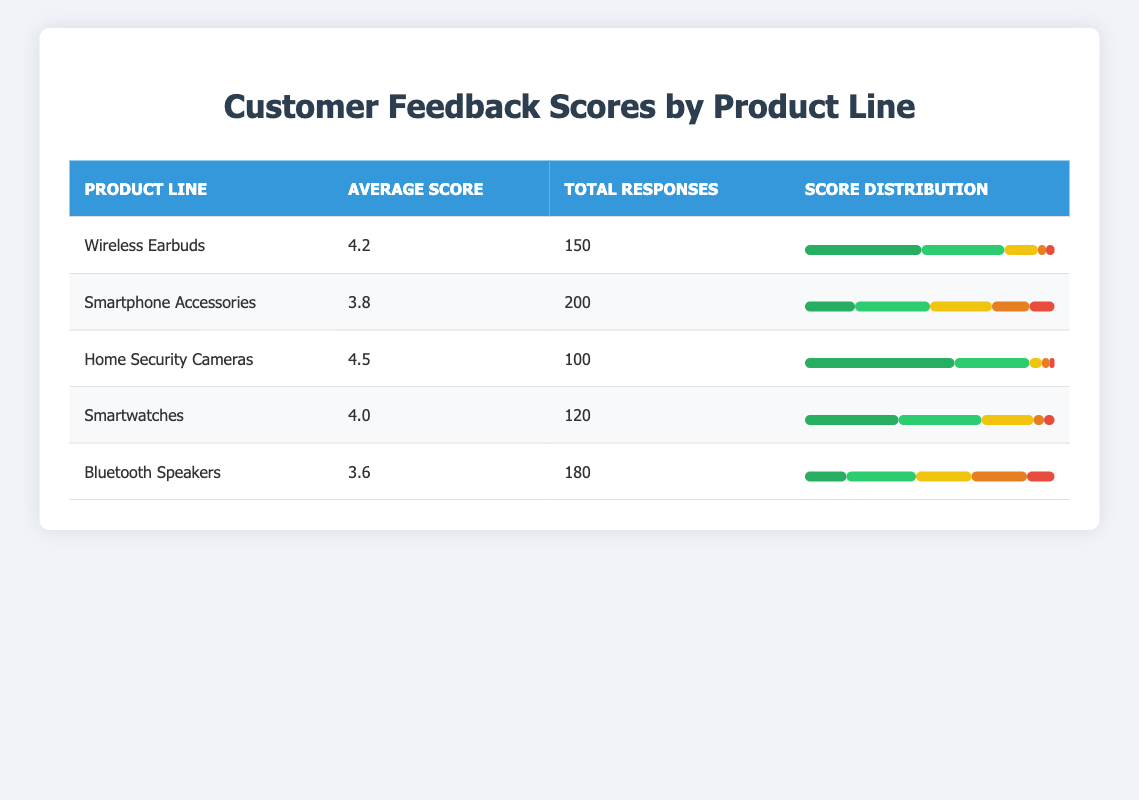What is the average feedback score for the Bluetooth Speakers? The average feedback score for the Bluetooth Speakers can be found directly in the table under the "Average Score" column, which is 3.6.
Answer: 3.6 How many total responses were received for the Home Security Cameras? The total responses for the Home Security Cameras are listed in the "Total Responses" column, which shows a total of 100 responses.
Answer: 100 What is the product line with the highest average feedback score? By comparing the average scores in the "Average Score" column, the Home Security Cameras have the highest score of 4.5.
Answer: Home Security Cameras What percentage of responses for Smartwatches were rated 5 stars? To find the percentage for Smartwatches, we take the number of 5-star ratings (45) out of the total responses (120). This results in (45/120) * 100 = 37.5%.
Answer: 37.5% Is the average feedback score for Smartphone Accessories greater than 4? The average feedback score for Smartphone Accessories is 3.8, which is less than 4. Thus, the statement is false.
Answer: No Which product line has the most total responses and what is the average score for that line? By checking the "Total Responses" column, the Smartphone Accessories have the most responses at 200. Their average feedback score is 3.8.
Answer: Smartphone Accessories, 3.8 What is the difference in average feedback scores between Wireless Earbuds and Bluetooth Speakers? The average score for Wireless Earbuds is 4.2 and for Bluetooth Speakers is 3.6. The difference is 4.2 - 3.6 = 0.6.
Answer: 0.6 How many responses received a score of 2 stars for the Smartwatch product line? The score distribution shows that there were 5 responses for the Smartwatch product line rated as 2 stars, found directly in the score distribution section.
Answer: 5 Is it true that Bluetooth Speakers received more 1-star ratings than the Home Security Cameras? The number of 1-star ratings for Bluetooth Speakers is 20, while for Home Security Cameras it is 2. Thus, it is true that Bluetooth Speakers received more 1-star ratings.
Answer: Yes 